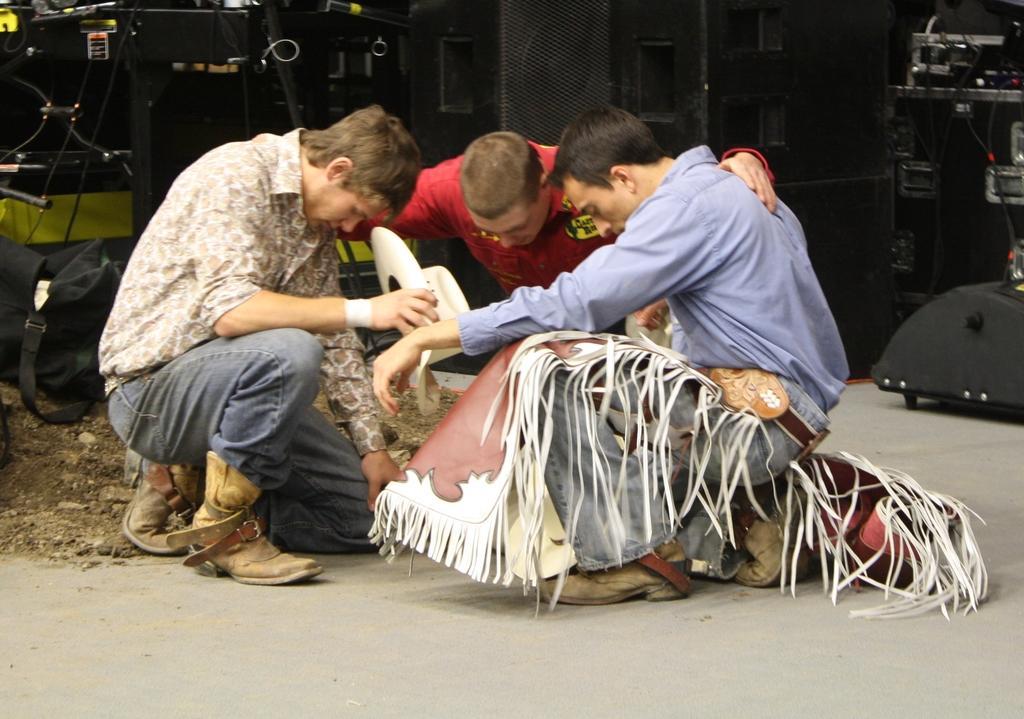In one or two sentences, can you explain what this image depicts? In this picture I can see three people sitting on the surface. I can see the speakers. I can see electronic devices in the background. 